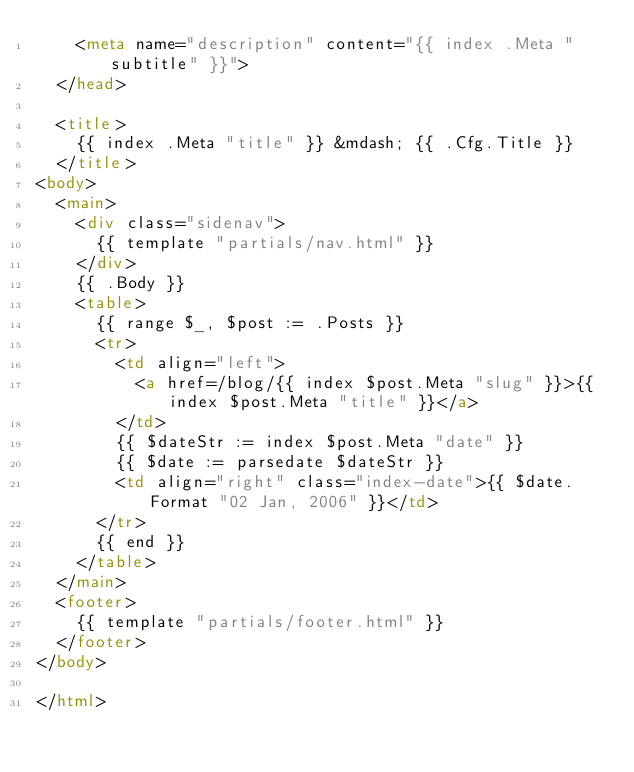Convert code to text. <code><loc_0><loc_0><loc_500><loc_500><_HTML_>    <meta name="description" content="{{ index .Meta "subtitle" }}">
  </head>

  <title>
    {{ index .Meta "title" }} &mdash; {{ .Cfg.Title }}
  </title>
<body>
  <main>
    <div class="sidenav">
      {{ template "partials/nav.html" }}
    </div>
    {{ .Body }}
    <table>
      {{ range $_, $post := .Posts }}
      <tr>
        <td align="left">
          <a href=/blog/{{ index $post.Meta "slug" }}>{{ index $post.Meta "title" }}</a>
        </td>
        {{ $dateStr := index $post.Meta "date" }}
        {{ $date := parsedate $dateStr }}
        <td align="right" class="index-date">{{ $date.Format "02 Jan, 2006" }}</td>
      </tr>
      {{ end }}
    </table>
  </main>
  <footer>
    {{ template "partials/footer.html" }}
  </footer>
</body>

</html>
</code> 